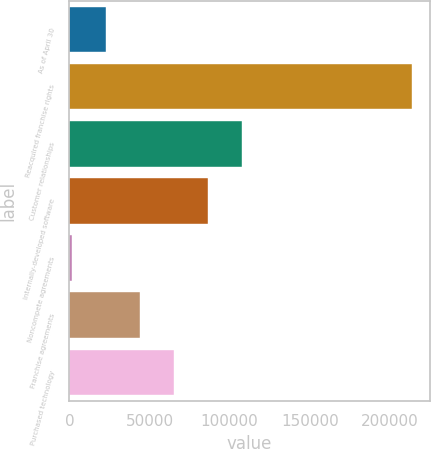Convert chart to OTSL. <chart><loc_0><loc_0><loc_500><loc_500><bar_chart><fcel>As of April 30<fcel>Reacquired franchise rights<fcel>Customer relationships<fcel>Internally-developed software<fcel>Noncompete agreements<fcel>Franchise agreements<fcel>Purchased technology<nl><fcel>23143.5<fcel>214065<fcel>107998<fcel>86784<fcel>1930<fcel>44357<fcel>65570.5<nl></chart> 